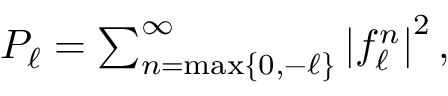<formula> <loc_0><loc_0><loc_500><loc_500>\begin{array} { r } { P _ { \ell } = \sum _ { n = \max \{ 0 , - \ell \} } ^ { \infty } \left | f _ { \ell } ^ { n } \right | ^ { 2 } , } \end{array}</formula> 